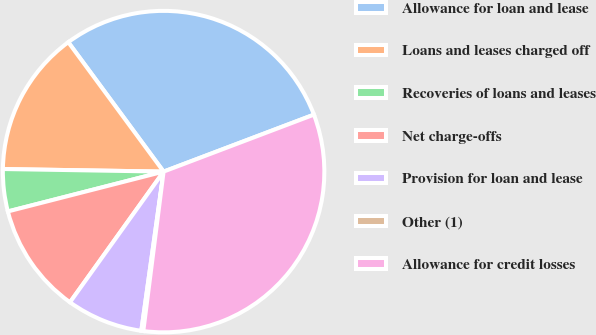<chart> <loc_0><loc_0><loc_500><loc_500><pie_chart><fcel>Allowance for loan and lease<fcel>Loans and leases charged off<fcel>Recoveries of loans and leases<fcel>Net charge-offs<fcel>Provision for loan and lease<fcel>Other (1)<fcel>Allowance for credit losses<nl><fcel>29.34%<fcel>14.64%<fcel>4.24%<fcel>11.12%<fcel>7.68%<fcel>0.2%<fcel>32.78%<nl></chart> 